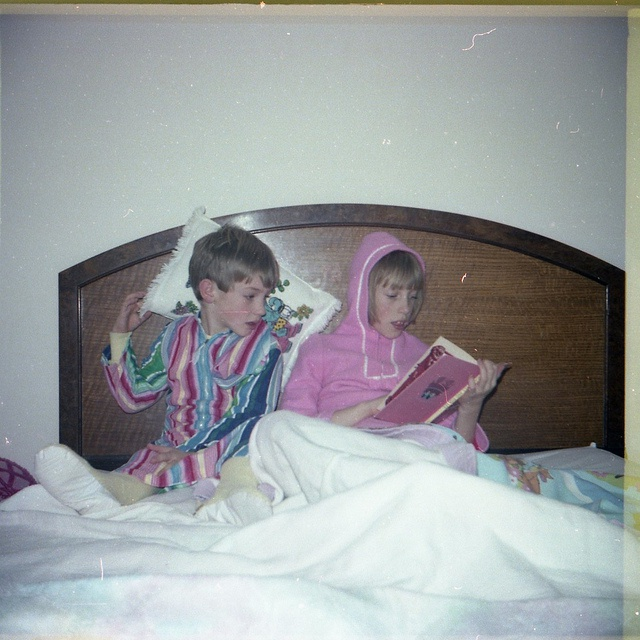Describe the objects in this image and their specific colors. I can see bed in olive, lightgray, darkgray, gray, and black tones, people in olive, darkgray, and gray tones, people in olive, violet, darkgray, and gray tones, and book in olive, purple, and darkgray tones in this image. 